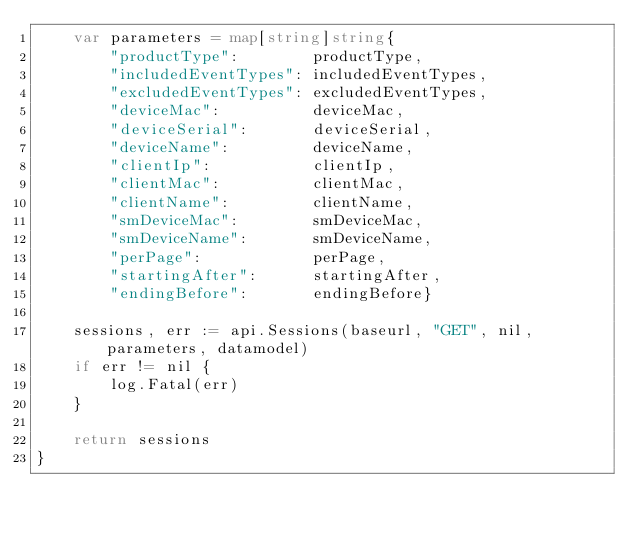Convert code to text. <code><loc_0><loc_0><loc_500><loc_500><_Go_>	var parameters = map[string]string{
		"productType":        productType,
		"includedEventTypes": includedEventTypes,
		"excludedEventTypes": excludedEventTypes,
		"deviceMac":          deviceMac,
		"deviceSerial":       deviceSerial,
		"deviceName":         deviceName,
		"clientIp":           clientIp,
		"clientMac":          clientMac,
		"clientName":         clientName,
		"smDeviceMac":        smDeviceMac,
		"smDeviceName":       smDeviceName,
		"perPage":            perPage,
		"startingAfter":      startingAfter,
		"endingBefore":       endingBefore}

	sessions, err := api.Sessions(baseurl, "GET", nil, parameters, datamodel)
	if err != nil {
		log.Fatal(err)
	}

	return sessions
}
</code> 